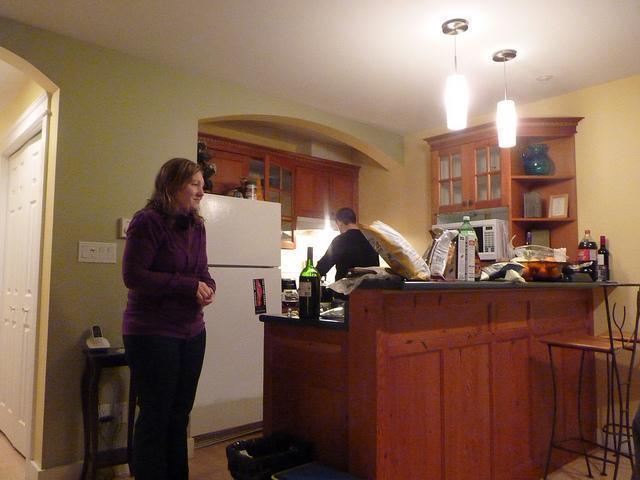How many people are there?
Give a very brief answer. 2. How many chairs are in the photo?
Give a very brief answer. 1. How many remotes are there?
Give a very brief answer. 0. 